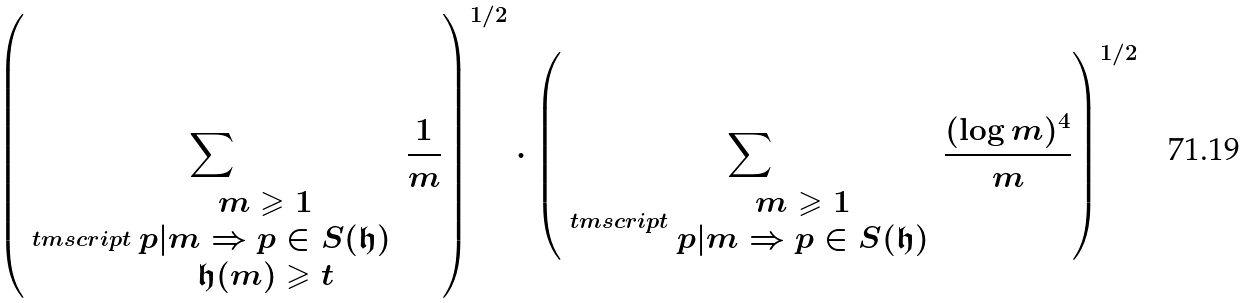<formula> <loc_0><loc_0><loc_500><loc_500>\left ( \sum _ { \ t m s c r i p t { \begin{array} { c } m \geqslant 1 \\ p | m \Rightarrow p \in S ( \mathfrak { h } ) \\ \mathfrak { h } ( m ) \geqslant t \end{array} } } \frac { 1 } { m } \right ) ^ { 1 / 2 } \cdot \left ( \sum _ { \ t m s c r i p t { \begin{array} { c } m \geqslant 1 \\ p | m \Rightarrow p \in S ( \mathfrak { h } ) \end{array} } } \frac { ( \log m ) ^ { 4 } } { m } \right ) ^ { 1 / 2 }</formula> 